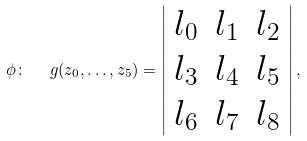Convert formula to latex. <formula><loc_0><loc_0><loc_500><loc_500>\phi \colon \ \ g ( z _ { 0 } , \dots , z _ { 5 } ) = \left | \begin{array} { c c c } l _ { 0 } & l _ { 1 } & l _ { 2 } \\ l _ { 3 } & l _ { 4 } & l _ { 5 } \\ l _ { 6 } & l _ { 7 } & l _ { 8 } \end{array} \right | ,</formula> 